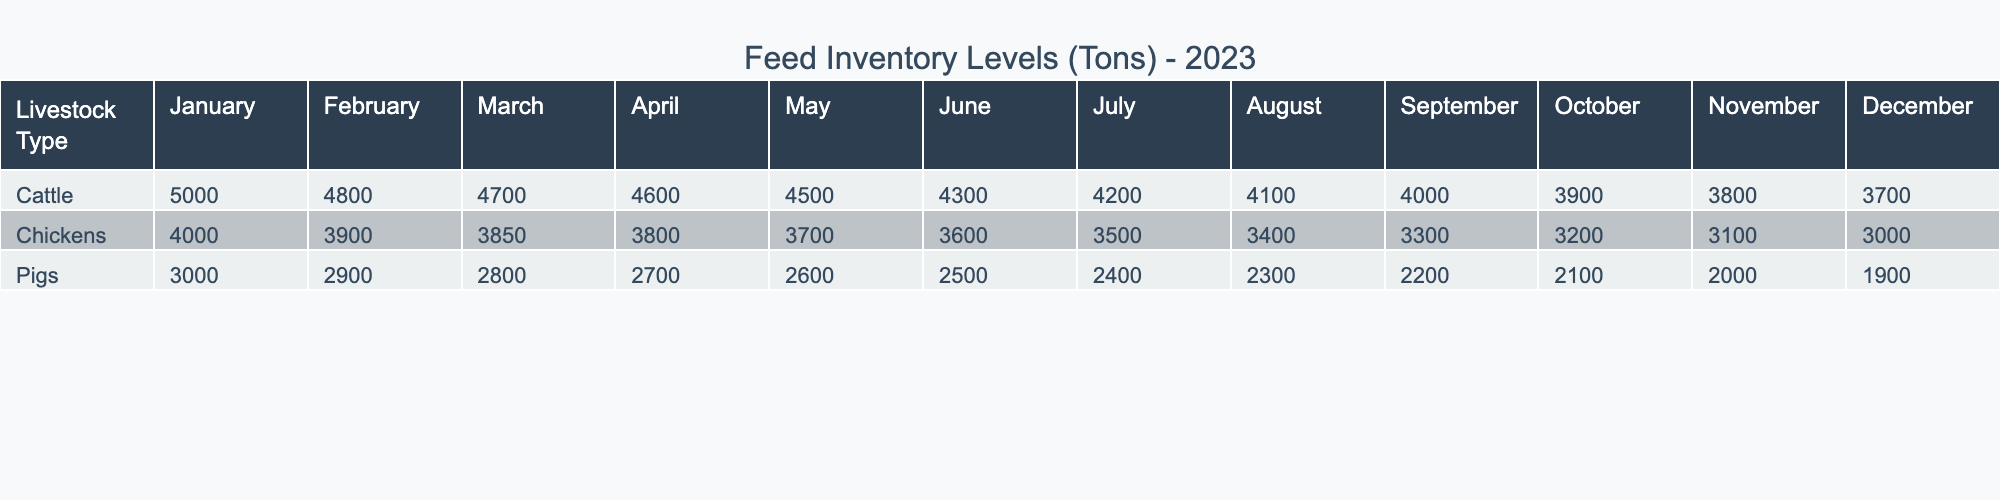What were the feed inventory levels for cattle in April 2023? According to the table, the feed inventory level for cattle in April is 4600 tons.
Answer: 4600 tons What is the total feed inventory level for pigs over the year 2023? To find this, sum the monthly feed inventory levels for pigs: 3000 + 2900 + 2800 + 2700 + 2600 + 2500 + 2400 + 2300 + 2200 + 2100 + 2000 + 1900 = 29900 tons.
Answer: 29900 tons Did the feed inventory level for chickens increase at any point in 2023? By reviewing the table, the inventory levels for chickens consistently decreased from January to December 2023, thus there was no increase.
Answer: No What is the average feed inventory level for cattle in 2023? The feed inventory levels for cattle from January to December are: 5000, 4800, 4700, 4600, 4500, 4300, 4200, 4100, 4000, 3900, 3800, 3700. Summing these gives  5000 + 4800 + 4700 + 4600 + 4500 + 4300 + 4200 + 4100 + 4000 + 3900 + 3800 + 3700 =  49900 tons. There are 12 months, so 49900 / 12 = 4158.33 tons.
Answer: 4158.33 tons What was the lowest feed inventory level for pigs in 2023? Inspecting the data, the lowest feed inventory level for pigs occurs in December, with a level of 1900 tons.
Answer: 1900 tons What feed inventory levels were recorded for chickens in July and August combined? First, the feed inventory for chickens in July is 3500 tons and in August is 3400 tons. The sum of these two months is 3500 + 3400 = 6900 tons.
Answer: 6900 tons Which livestock type had the highest feed inventory level in January 2023? By looking at the table, the feed levels are 5000 tons for cattle, 3000 tons for pigs, and 4000 tons for chickens in January. The highest among these is for cattle at 5000 tons.
Answer: Cattle 